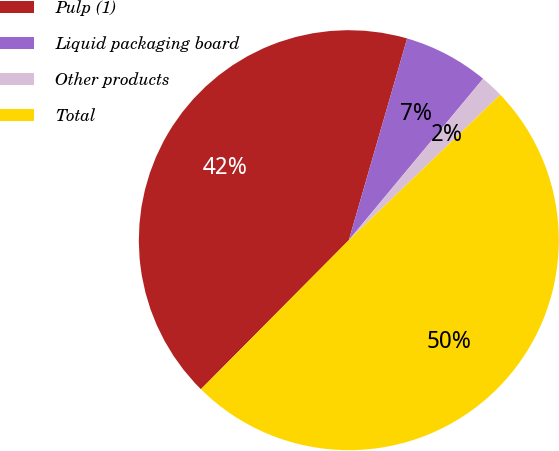Convert chart to OTSL. <chart><loc_0><loc_0><loc_500><loc_500><pie_chart><fcel>Pulp (1)<fcel>Liquid packaging board<fcel>Other products<fcel>Total<nl><fcel>42.04%<fcel>6.56%<fcel>1.78%<fcel>49.62%<nl></chart> 